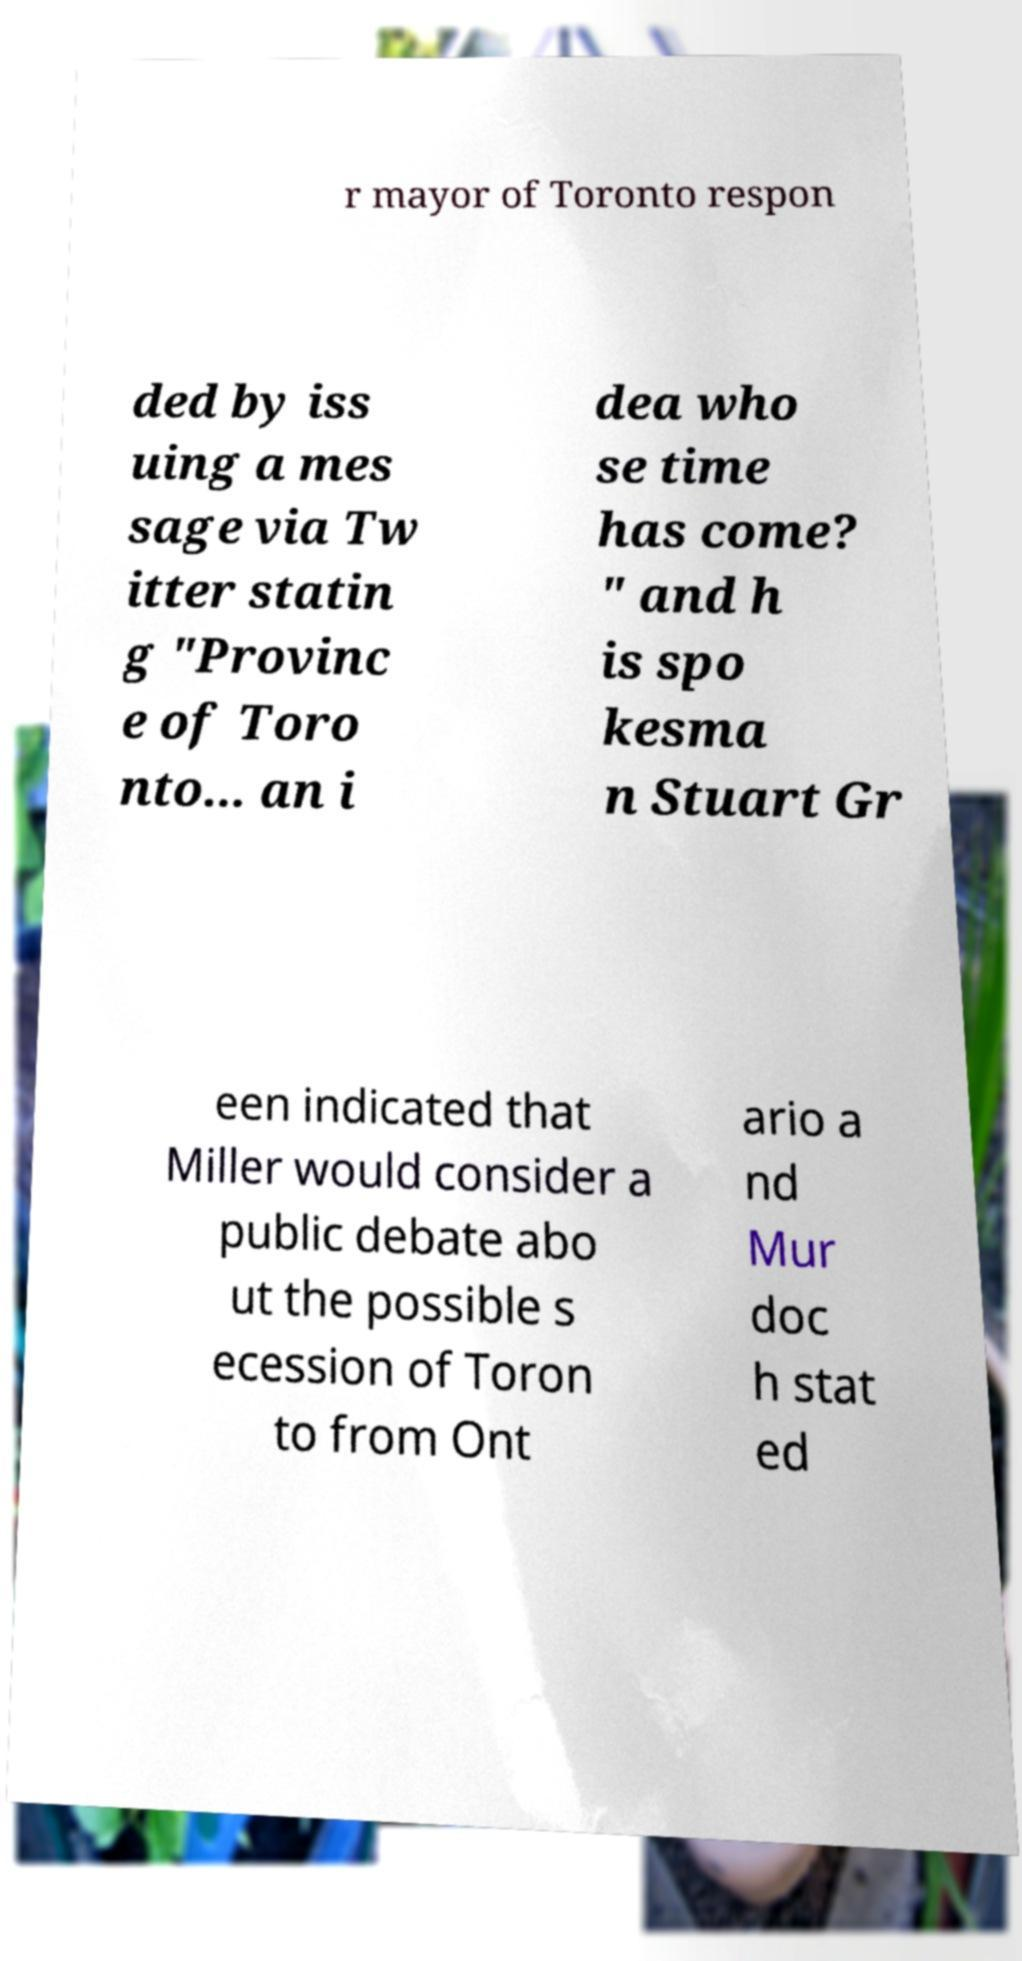Could you assist in decoding the text presented in this image and type it out clearly? r mayor of Toronto respon ded by iss uing a mes sage via Tw itter statin g "Provinc e of Toro nto... an i dea who se time has come? " and h is spo kesma n Stuart Gr een indicated that Miller would consider a public debate abo ut the possible s ecession of Toron to from Ont ario a nd Mur doc h stat ed 